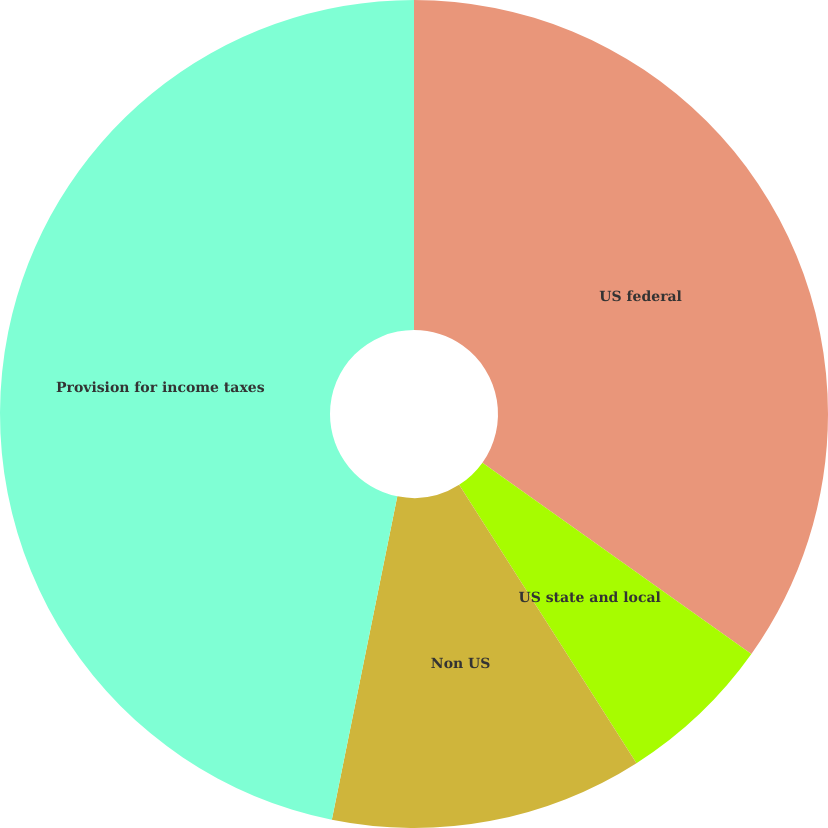Convert chart. <chart><loc_0><loc_0><loc_500><loc_500><pie_chart><fcel>US federal<fcel>US state and local<fcel>Non US<fcel>Provision for income taxes<nl><fcel>34.84%<fcel>6.13%<fcel>12.21%<fcel>46.82%<nl></chart> 